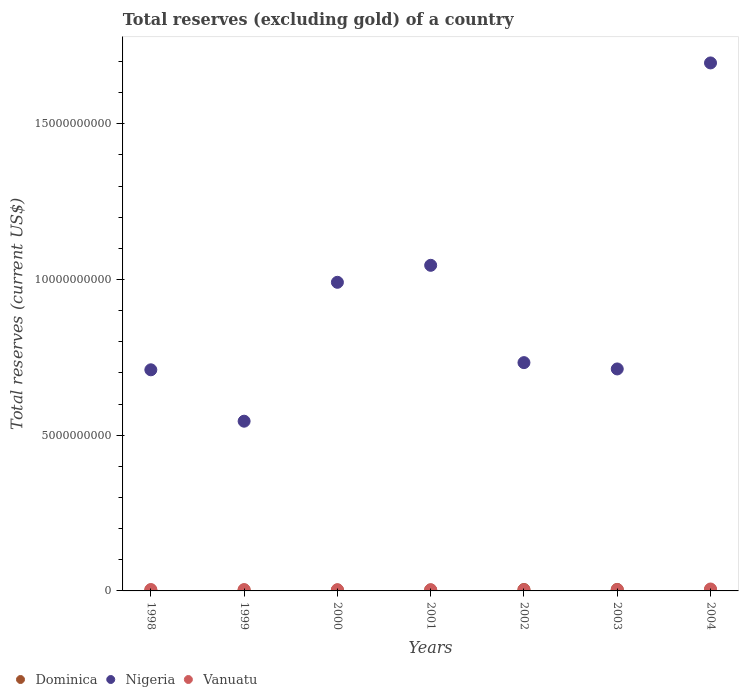How many different coloured dotlines are there?
Keep it short and to the point. 3. What is the total reserves (excluding gold) in Vanuatu in 1998?
Provide a succinct answer. 4.47e+07. Across all years, what is the maximum total reserves (excluding gold) in Dominica?
Provide a succinct answer. 4.77e+07. Across all years, what is the minimum total reserves (excluding gold) in Nigeria?
Provide a short and direct response. 5.45e+09. In which year was the total reserves (excluding gold) in Dominica maximum?
Your response must be concise. 2003. What is the total total reserves (excluding gold) in Dominica in the graph?
Make the answer very short. 2.55e+08. What is the difference between the total reserves (excluding gold) in Nigeria in 2000 and that in 2003?
Your response must be concise. 2.78e+09. What is the difference between the total reserves (excluding gold) in Vanuatu in 1999 and the total reserves (excluding gold) in Nigeria in 2000?
Your answer should be very brief. -9.87e+09. What is the average total reserves (excluding gold) in Dominica per year?
Ensure brevity in your answer.  3.65e+07. In the year 2002, what is the difference between the total reserves (excluding gold) in Vanuatu and total reserves (excluding gold) in Nigeria?
Provide a short and direct response. -7.29e+09. In how many years, is the total reserves (excluding gold) in Dominica greater than 8000000000 US$?
Provide a short and direct response. 0. What is the ratio of the total reserves (excluding gold) in Nigeria in 1999 to that in 2000?
Offer a very short reply. 0.55. Is the difference between the total reserves (excluding gold) in Vanuatu in 1998 and 2002 greater than the difference between the total reserves (excluding gold) in Nigeria in 1998 and 2002?
Provide a short and direct response. Yes. What is the difference between the highest and the second highest total reserves (excluding gold) in Vanuatu?
Your response must be concise. 1.71e+07. What is the difference between the highest and the lowest total reserves (excluding gold) in Dominica?
Ensure brevity in your answer.  2.01e+07. In how many years, is the total reserves (excluding gold) in Dominica greater than the average total reserves (excluding gold) in Dominica taken over all years?
Provide a succinct answer. 3. Is it the case that in every year, the sum of the total reserves (excluding gold) in Nigeria and total reserves (excluding gold) in Vanuatu  is greater than the total reserves (excluding gold) in Dominica?
Make the answer very short. Yes. Does the total reserves (excluding gold) in Nigeria monotonically increase over the years?
Provide a short and direct response. No. Is the total reserves (excluding gold) in Nigeria strictly less than the total reserves (excluding gold) in Vanuatu over the years?
Keep it short and to the point. No. Where does the legend appear in the graph?
Your answer should be very brief. Bottom left. How are the legend labels stacked?
Offer a very short reply. Horizontal. What is the title of the graph?
Give a very brief answer. Total reserves (excluding gold) of a country. Does "Angola" appear as one of the legend labels in the graph?
Your response must be concise. No. What is the label or title of the Y-axis?
Your answer should be very brief. Total reserves (current US$). What is the Total reserves (current US$) in Dominica in 1998?
Offer a very short reply. 2.77e+07. What is the Total reserves (current US$) in Nigeria in 1998?
Keep it short and to the point. 7.10e+09. What is the Total reserves (current US$) of Vanuatu in 1998?
Your response must be concise. 4.47e+07. What is the Total reserves (current US$) in Dominica in 1999?
Provide a succinct answer. 3.16e+07. What is the Total reserves (current US$) of Nigeria in 1999?
Provide a succinct answer. 5.45e+09. What is the Total reserves (current US$) in Vanuatu in 1999?
Your response must be concise. 4.14e+07. What is the Total reserves (current US$) in Dominica in 2000?
Make the answer very short. 2.94e+07. What is the Total reserves (current US$) of Nigeria in 2000?
Give a very brief answer. 9.91e+09. What is the Total reserves (current US$) in Vanuatu in 2000?
Offer a terse response. 3.89e+07. What is the Total reserves (current US$) in Dominica in 2001?
Keep it short and to the point. 3.12e+07. What is the Total reserves (current US$) of Nigeria in 2001?
Give a very brief answer. 1.05e+1. What is the Total reserves (current US$) in Vanuatu in 2001?
Your response must be concise. 3.77e+07. What is the Total reserves (current US$) in Dominica in 2002?
Your answer should be very brief. 4.55e+07. What is the Total reserves (current US$) in Nigeria in 2002?
Ensure brevity in your answer.  7.33e+09. What is the Total reserves (current US$) of Vanuatu in 2002?
Give a very brief answer. 3.65e+07. What is the Total reserves (current US$) in Dominica in 2003?
Offer a very short reply. 4.77e+07. What is the Total reserves (current US$) of Nigeria in 2003?
Ensure brevity in your answer.  7.13e+09. What is the Total reserves (current US$) in Vanuatu in 2003?
Ensure brevity in your answer.  4.38e+07. What is the Total reserves (current US$) in Dominica in 2004?
Offer a terse response. 4.23e+07. What is the Total reserves (current US$) of Nigeria in 2004?
Your answer should be very brief. 1.70e+1. What is the Total reserves (current US$) in Vanuatu in 2004?
Offer a very short reply. 6.18e+07. Across all years, what is the maximum Total reserves (current US$) of Dominica?
Your response must be concise. 4.77e+07. Across all years, what is the maximum Total reserves (current US$) in Nigeria?
Make the answer very short. 1.70e+1. Across all years, what is the maximum Total reserves (current US$) in Vanuatu?
Your answer should be compact. 6.18e+07. Across all years, what is the minimum Total reserves (current US$) of Dominica?
Offer a terse response. 2.77e+07. Across all years, what is the minimum Total reserves (current US$) in Nigeria?
Provide a short and direct response. 5.45e+09. Across all years, what is the minimum Total reserves (current US$) of Vanuatu?
Your answer should be very brief. 3.65e+07. What is the total Total reserves (current US$) of Dominica in the graph?
Make the answer very short. 2.55e+08. What is the total Total reserves (current US$) in Nigeria in the graph?
Give a very brief answer. 6.43e+1. What is the total Total reserves (current US$) in Vanuatu in the graph?
Provide a succinct answer. 3.05e+08. What is the difference between the Total reserves (current US$) in Dominica in 1998 and that in 1999?
Ensure brevity in your answer.  -3.91e+06. What is the difference between the Total reserves (current US$) of Nigeria in 1998 and that in 1999?
Your answer should be very brief. 1.65e+09. What is the difference between the Total reserves (current US$) of Vanuatu in 1998 and that in 1999?
Keep it short and to the point. 3.32e+06. What is the difference between the Total reserves (current US$) in Dominica in 1998 and that in 2000?
Keep it short and to the point. -1.71e+06. What is the difference between the Total reserves (current US$) of Nigeria in 1998 and that in 2000?
Provide a succinct answer. -2.81e+09. What is the difference between the Total reserves (current US$) in Vanuatu in 1998 and that in 2000?
Your answer should be very brief. 5.75e+06. What is the difference between the Total reserves (current US$) in Dominica in 1998 and that in 2001?
Keep it short and to the point. -3.56e+06. What is the difference between the Total reserves (current US$) of Nigeria in 1998 and that in 2001?
Offer a terse response. -3.36e+09. What is the difference between the Total reserves (current US$) of Vanuatu in 1998 and that in 2001?
Give a very brief answer. 7.01e+06. What is the difference between the Total reserves (current US$) in Dominica in 1998 and that in 2002?
Offer a terse response. -1.78e+07. What is the difference between the Total reserves (current US$) in Nigeria in 1998 and that in 2002?
Offer a terse response. -2.31e+08. What is the difference between the Total reserves (current US$) of Vanuatu in 1998 and that in 2002?
Keep it short and to the point. 8.15e+06. What is the difference between the Total reserves (current US$) of Dominica in 1998 and that in 2003?
Your response must be concise. -2.01e+07. What is the difference between the Total reserves (current US$) of Nigeria in 1998 and that in 2003?
Offer a terse response. -2.76e+07. What is the difference between the Total reserves (current US$) in Vanuatu in 1998 and that in 2003?
Give a very brief answer. 8.53e+05. What is the difference between the Total reserves (current US$) in Dominica in 1998 and that in 2004?
Make the answer very short. -1.47e+07. What is the difference between the Total reserves (current US$) in Nigeria in 1998 and that in 2004?
Provide a short and direct response. -9.85e+09. What is the difference between the Total reserves (current US$) of Vanuatu in 1998 and that in 2004?
Offer a very short reply. -1.71e+07. What is the difference between the Total reserves (current US$) in Dominica in 1999 and that in 2000?
Provide a succinct answer. 2.20e+06. What is the difference between the Total reserves (current US$) in Nigeria in 1999 and that in 2000?
Your response must be concise. -4.46e+09. What is the difference between the Total reserves (current US$) in Vanuatu in 1999 and that in 2000?
Your answer should be very brief. 2.43e+06. What is the difference between the Total reserves (current US$) in Dominica in 1999 and that in 2001?
Your answer should be compact. 3.50e+05. What is the difference between the Total reserves (current US$) in Nigeria in 1999 and that in 2001?
Make the answer very short. -5.01e+09. What is the difference between the Total reserves (current US$) in Vanuatu in 1999 and that in 2001?
Make the answer very short. 3.70e+06. What is the difference between the Total reserves (current US$) of Dominica in 1999 and that in 2002?
Your answer should be compact. -1.39e+07. What is the difference between the Total reserves (current US$) in Nigeria in 1999 and that in 2002?
Offer a very short reply. -1.88e+09. What is the difference between the Total reserves (current US$) in Vanuatu in 1999 and that in 2002?
Provide a short and direct response. 4.83e+06. What is the difference between the Total reserves (current US$) of Dominica in 1999 and that in 2003?
Provide a succinct answer. -1.62e+07. What is the difference between the Total reserves (current US$) in Nigeria in 1999 and that in 2003?
Offer a very short reply. -1.68e+09. What is the difference between the Total reserves (current US$) in Vanuatu in 1999 and that in 2003?
Make the answer very short. -2.46e+06. What is the difference between the Total reserves (current US$) in Dominica in 1999 and that in 2004?
Provide a short and direct response. -1.07e+07. What is the difference between the Total reserves (current US$) of Nigeria in 1999 and that in 2004?
Make the answer very short. -1.15e+1. What is the difference between the Total reserves (current US$) of Vanuatu in 1999 and that in 2004?
Your answer should be compact. -2.05e+07. What is the difference between the Total reserves (current US$) of Dominica in 2000 and that in 2001?
Your answer should be compact. -1.85e+06. What is the difference between the Total reserves (current US$) in Nigeria in 2000 and that in 2001?
Keep it short and to the point. -5.46e+08. What is the difference between the Total reserves (current US$) of Vanuatu in 2000 and that in 2001?
Offer a terse response. 1.26e+06. What is the difference between the Total reserves (current US$) of Dominica in 2000 and that in 2002?
Offer a very short reply. -1.61e+07. What is the difference between the Total reserves (current US$) in Nigeria in 2000 and that in 2002?
Offer a terse response. 2.58e+09. What is the difference between the Total reserves (current US$) of Vanuatu in 2000 and that in 2002?
Ensure brevity in your answer.  2.40e+06. What is the difference between the Total reserves (current US$) in Dominica in 2000 and that in 2003?
Your answer should be very brief. -1.84e+07. What is the difference between the Total reserves (current US$) in Nigeria in 2000 and that in 2003?
Give a very brief answer. 2.78e+09. What is the difference between the Total reserves (current US$) of Vanuatu in 2000 and that in 2003?
Your answer should be very brief. -4.89e+06. What is the difference between the Total reserves (current US$) in Dominica in 2000 and that in 2004?
Provide a short and direct response. -1.29e+07. What is the difference between the Total reserves (current US$) in Nigeria in 2000 and that in 2004?
Your response must be concise. -7.04e+09. What is the difference between the Total reserves (current US$) of Vanuatu in 2000 and that in 2004?
Your answer should be compact. -2.29e+07. What is the difference between the Total reserves (current US$) of Dominica in 2001 and that in 2002?
Offer a very short reply. -1.43e+07. What is the difference between the Total reserves (current US$) in Nigeria in 2001 and that in 2002?
Your answer should be very brief. 3.13e+09. What is the difference between the Total reserves (current US$) in Vanuatu in 2001 and that in 2002?
Provide a short and direct response. 1.14e+06. What is the difference between the Total reserves (current US$) of Dominica in 2001 and that in 2003?
Offer a terse response. -1.65e+07. What is the difference between the Total reserves (current US$) of Nigeria in 2001 and that in 2003?
Offer a very short reply. 3.33e+09. What is the difference between the Total reserves (current US$) of Vanuatu in 2001 and that in 2003?
Provide a short and direct response. -6.16e+06. What is the difference between the Total reserves (current US$) of Dominica in 2001 and that in 2004?
Provide a succinct answer. -1.11e+07. What is the difference between the Total reserves (current US$) of Nigeria in 2001 and that in 2004?
Offer a very short reply. -6.50e+09. What is the difference between the Total reserves (current US$) in Vanuatu in 2001 and that in 2004?
Ensure brevity in your answer.  -2.42e+07. What is the difference between the Total reserves (current US$) of Dominica in 2002 and that in 2003?
Provide a short and direct response. -2.24e+06. What is the difference between the Total reserves (current US$) of Nigeria in 2002 and that in 2003?
Your answer should be very brief. 2.03e+08. What is the difference between the Total reserves (current US$) of Vanuatu in 2002 and that in 2003?
Provide a succinct answer. -7.29e+06. What is the difference between the Total reserves (current US$) of Dominica in 2002 and that in 2004?
Provide a short and direct response. 3.18e+06. What is the difference between the Total reserves (current US$) of Nigeria in 2002 and that in 2004?
Your response must be concise. -9.62e+09. What is the difference between the Total reserves (current US$) of Vanuatu in 2002 and that in 2004?
Your response must be concise. -2.53e+07. What is the difference between the Total reserves (current US$) in Dominica in 2003 and that in 2004?
Offer a terse response. 5.41e+06. What is the difference between the Total reserves (current US$) of Nigeria in 2003 and that in 2004?
Ensure brevity in your answer.  -9.83e+09. What is the difference between the Total reserves (current US$) in Vanuatu in 2003 and that in 2004?
Offer a very short reply. -1.80e+07. What is the difference between the Total reserves (current US$) of Dominica in 1998 and the Total reserves (current US$) of Nigeria in 1999?
Provide a short and direct response. -5.42e+09. What is the difference between the Total reserves (current US$) of Dominica in 1998 and the Total reserves (current US$) of Vanuatu in 1999?
Provide a succinct answer. -1.37e+07. What is the difference between the Total reserves (current US$) of Nigeria in 1998 and the Total reserves (current US$) of Vanuatu in 1999?
Keep it short and to the point. 7.06e+09. What is the difference between the Total reserves (current US$) in Dominica in 1998 and the Total reserves (current US$) in Nigeria in 2000?
Offer a very short reply. -9.88e+09. What is the difference between the Total reserves (current US$) in Dominica in 1998 and the Total reserves (current US$) in Vanuatu in 2000?
Offer a terse response. -1.13e+07. What is the difference between the Total reserves (current US$) of Nigeria in 1998 and the Total reserves (current US$) of Vanuatu in 2000?
Your response must be concise. 7.06e+09. What is the difference between the Total reserves (current US$) in Dominica in 1998 and the Total reserves (current US$) in Nigeria in 2001?
Make the answer very short. -1.04e+1. What is the difference between the Total reserves (current US$) in Dominica in 1998 and the Total reserves (current US$) in Vanuatu in 2001?
Make the answer very short. -9.99e+06. What is the difference between the Total reserves (current US$) in Nigeria in 1998 and the Total reserves (current US$) in Vanuatu in 2001?
Offer a very short reply. 7.06e+09. What is the difference between the Total reserves (current US$) of Dominica in 1998 and the Total reserves (current US$) of Nigeria in 2002?
Keep it short and to the point. -7.30e+09. What is the difference between the Total reserves (current US$) in Dominica in 1998 and the Total reserves (current US$) in Vanuatu in 2002?
Provide a short and direct response. -8.86e+06. What is the difference between the Total reserves (current US$) of Nigeria in 1998 and the Total reserves (current US$) of Vanuatu in 2002?
Offer a very short reply. 7.06e+09. What is the difference between the Total reserves (current US$) of Dominica in 1998 and the Total reserves (current US$) of Nigeria in 2003?
Offer a terse response. -7.10e+09. What is the difference between the Total reserves (current US$) of Dominica in 1998 and the Total reserves (current US$) of Vanuatu in 2003?
Keep it short and to the point. -1.62e+07. What is the difference between the Total reserves (current US$) of Nigeria in 1998 and the Total reserves (current US$) of Vanuatu in 2003?
Keep it short and to the point. 7.06e+09. What is the difference between the Total reserves (current US$) in Dominica in 1998 and the Total reserves (current US$) in Nigeria in 2004?
Give a very brief answer. -1.69e+1. What is the difference between the Total reserves (current US$) of Dominica in 1998 and the Total reserves (current US$) of Vanuatu in 2004?
Your answer should be very brief. -3.41e+07. What is the difference between the Total reserves (current US$) in Nigeria in 1998 and the Total reserves (current US$) in Vanuatu in 2004?
Provide a short and direct response. 7.04e+09. What is the difference between the Total reserves (current US$) in Dominica in 1999 and the Total reserves (current US$) in Nigeria in 2000?
Keep it short and to the point. -9.88e+09. What is the difference between the Total reserves (current US$) in Dominica in 1999 and the Total reserves (current US$) in Vanuatu in 2000?
Offer a very short reply. -7.35e+06. What is the difference between the Total reserves (current US$) in Nigeria in 1999 and the Total reserves (current US$) in Vanuatu in 2000?
Offer a very short reply. 5.41e+09. What is the difference between the Total reserves (current US$) in Dominica in 1999 and the Total reserves (current US$) in Nigeria in 2001?
Offer a terse response. -1.04e+1. What is the difference between the Total reserves (current US$) of Dominica in 1999 and the Total reserves (current US$) of Vanuatu in 2001?
Your response must be concise. -6.08e+06. What is the difference between the Total reserves (current US$) of Nigeria in 1999 and the Total reserves (current US$) of Vanuatu in 2001?
Offer a terse response. 5.41e+09. What is the difference between the Total reserves (current US$) in Dominica in 1999 and the Total reserves (current US$) in Nigeria in 2002?
Provide a short and direct response. -7.30e+09. What is the difference between the Total reserves (current US$) in Dominica in 1999 and the Total reserves (current US$) in Vanuatu in 2002?
Provide a short and direct response. -4.95e+06. What is the difference between the Total reserves (current US$) in Nigeria in 1999 and the Total reserves (current US$) in Vanuatu in 2002?
Give a very brief answer. 5.41e+09. What is the difference between the Total reserves (current US$) in Dominica in 1999 and the Total reserves (current US$) in Nigeria in 2003?
Offer a terse response. -7.10e+09. What is the difference between the Total reserves (current US$) of Dominica in 1999 and the Total reserves (current US$) of Vanuatu in 2003?
Keep it short and to the point. -1.22e+07. What is the difference between the Total reserves (current US$) in Nigeria in 1999 and the Total reserves (current US$) in Vanuatu in 2003?
Keep it short and to the point. 5.41e+09. What is the difference between the Total reserves (current US$) of Dominica in 1999 and the Total reserves (current US$) of Nigeria in 2004?
Give a very brief answer. -1.69e+1. What is the difference between the Total reserves (current US$) in Dominica in 1999 and the Total reserves (current US$) in Vanuatu in 2004?
Keep it short and to the point. -3.02e+07. What is the difference between the Total reserves (current US$) in Nigeria in 1999 and the Total reserves (current US$) in Vanuatu in 2004?
Keep it short and to the point. 5.39e+09. What is the difference between the Total reserves (current US$) in Dominica in 2000 and the Total reserves (current US$) in Nigeria in 2001?
Provide a short and direct response. -1.04e+1. What is the difference between the Total reserves (current US$) in Dominica in 2000 and the Total reserves (current US$) in Vanuatu in 2001?
Your answer should be compact. -8.29e+06. What is the difference between the Total reserves (current US$) in Nigeria in 2000 and the Total reserves (current US$) in Vanuatu in 2001?
Offer a very short reply. 9.87e+09. What is the difference between the Total reserves (current US$) in Dominica in 2000 and the Total reserves (current US$) in Nigeria in 2002?
Your answer should be very brief. -7.30e+09. What is the difference between the Total reserves (current US$) of Dominica in 2000 and the Total reserves (current US$) of Vanuatu in 2002?
Offer a very short reply. -7.15e+06. What is the difference between the Total reserves (current US$) in Nigeria in 2000 and the Total reserves (current US$) in Vanuatu in 2002?
Offer a terse response. 9.87e+09. What is the difference between the Total reserves (current US$) of Dominica in 2000 and the Total reserves (current US$) of Nigeria in 2003?
Provide a short and direct response. -7.10e+09. What is the difference between the Total reserves (current US$) of Dominica in 2000 and the Total reserves (current US$) of Vanuatu in 2003?
Ensure brevity in your answer.  -1.44e+07. What is the difference between the Total reserves (current US$) in Nigeria in 2000 and the Total reserves (current US$) in Vanuatu in 2003?
Make the answer very short. 9.87e+09. What is the difference between the Total reserves (current US$) of Dominica in 2000 and the Total reserves (current US$) of Nigeria in 2004?
Offer a very short reply. -1.69e+1. What is the difference between the Total reserves (current US$) of Dominica in 2000 and the Total reserves (current US$) of Vanuatu in 2004?
Ensure brevity in your answer.  -3.24e+07. What is the difference between the Total reserves (current US$) of Nigeria in 2000 and the Total reserves (current US$) of Vanuatu in 2004?
Your answer should be compact. 9.85e+09. What is the difference between the Total reserves (current US$) in Dominica in 2001 and the Total reserves (current US$) in Nigeria in 2002?
Your response must be concise. -7.30e+09. What is the difference between the Total reserves (current US$) of Dominica in 2001 and the Total reserves (current US$) of Vanuatu in 2002?
Your response must be concise. -5.30e+06. What is the difference between the Total reserves (current US$) of Nigeria in 2001 and the Total reserves (current US$) of Vanuatu in 2002?
Your response must be concise. 1.04e+1. What is the difference between the Total reserves (current US$) in Dominica in 2001 and the Total reserves (current US$) in Nigeria in 2003?
Give a very brief answer. -7.10e+09. What is the difference between the Total reserves (current US$) in Dominica in 2001 and the Total reserves (current US$) in Vanuatu in 2003?
Your response must be concise. -1.26e+07. What is the difference between the Total reserves (current US$) of Nigeria in 2001 and the Total reserves (current US$) of Vanuatu in 2003?
Your answer should be very brief. 1.04e+1. What is the difference between the Total reserves (current US$) in Dominica in 2001 and the Total reserves (current US$) in Nigeria in 2004?
Make the answer very short. -1.69e+1. What is the difference between the Total reserves (current US$) of Dominica in 2001 and the Total reserves (current US$) of Vanuatu in 2004?
Offer a terse response. -3.06e+07. What is the difference between the Total reserves (current US$) in Nigeria in 2001 and the Total reserves (current US$) in Vanuatu in 2004?
Provide a short and direct response. 1.04e+1. What is the difference between the Total reserves (current US$) of Dominica in 2002 and the Total reserves (current US$) of Nigeria in 2003?
Offer a terse response. -7.08e+09. What is the difference between the Total reserves (current US$) in Dominica in 2002 and the Total reserves (current US$) in Vanuatu in 2003?
Keep it short and to the point. 1.68e+06. What is the difference between the Total reserves (current US$) in Nigeria in 2002 and the Total reserves (current US$) in Vanuatu in 2003?
Your response must be concise. 7.29e+09. What is the difference between the Total reserves (current US$) of Dominica in 2002 and the Total reserves (current US$) of Nigeria in 2004?
Ensure brevity in your answer.  -1.69e+1. What is the difference between the Total reserves (current US$) of Dominica in 2002 and the Total reserves (current US$) of Vanuatu in 2004?
Offer a terse response. -1.63e+07. What is the difference between the Total reserves (current US$) of Nigeria in 2002 and the Total reserves (current US$) of Vanuatu in 2004?
Offer a terse response. 7.27e+09. What is the difference between the Total reserves (current US$) of Dominica in 2003 and the Total reserves (current US$) of Nigeria in 2004?
Provide a succinct answer. -1.69e+1. What is the difference between the Total reserves (current US$) in Dominica in 2003 and the Total reserves (current US$) in Vanuatu in 2004?
Your response must be concise. -1.41e+07. What is the difference between the Total reserves (current US$) in Nigeria in 2003 and the Total reserves (current US$) in Vanuatu in 2004?
Ensure brevity in your answer.  7.07e+09. What is the average Total reserves (current US$) of Dominica per year?
Provide a succinct answer. 3.65e+07. What is the average Total reserves (current US$) of Nigeria per year?
Your response must be concise. 9.19e+09. What is the average Total reserves (current US$) of Vanuatu per year?
Provide a short and direct response. 4.35e+07. In the year 1998, what is the difference between the Total reserves (current US$) in Dominica and Total reserves (current US$) in Nigeria?
Provide a succinct answer. -7.07e+09. In the year 1998, what is the difference between the Total reserves (current US$) in Dominica and Total reserves (current US$) in Vanuatu?
Provide a succinct answer. -1.70e+07. In the year 1998, what is the difference between the Total reserves (current US$) of Nigeria and Total reserves (current US$) of Vanuatu?
Provide a succinct answer. 7.06e+09. In the year 1999, what is the difference between the Total reserves (current US$) of Dominica and Total reserves (current US$) of Nigeria?
Offer a very short reply. -5.42e+09. In the year 1999, what is the difference between the Total reserves (current US$) of Dominica and Total reserves (current US$) of Vanuatu?
Keep it short and to the point. -9.78e+06. In the year 1999, what is the difference between the Total reserves (current US$) in Nigeria and Total reserves (current US$) in Vanuatu?
Provide a succinct answer. 5.41e+09. In the year 2000, what is the difference between the Total reserves (current US$) in Dominica and Total reserves (current US$) in Nigeria?
Offer a terse response. -9.88e+09. In the year 2000, what is the difference between the Total reserves (current US$) of Dominica and Total reserves (current US$) of Vanuatu?
Keep it short and to the point. -9.55e+06. In the year 2000, what is the difference between the Total reserves (current US$) of Nigeria and Total reserves (current US$) of Vanuatu?
Make the answer very short. 9.87e+09. In the year 2001, what is the difference between the Total reserves (current US$) in Dominica and Total reserves (current US$) in Nigeria?
Your answer should be compact. -1.04e+1. In the year 2001, what is the difference between the Total reserves (current US$) in Dominica and Total reserves (current US$) in Vanuatu?
Ensure brevity in your answer.  -6.43e+06. In the year 2001, what is the difference between the Total reserves (current US$) in Nigeria and Total reserves (current US$) in Vanuatu?
Your response must be concise. 1.04e+1. In the year 2002, what is the difference between the Total reserves (current US$) of Dominica and Total reserves (current US$) of Nigeria?
Your answer should be compact. -7.29e+09. In the year 2002, what is the difference between the Total reserves (current US$) in Dominica and Total reserves (current US$) in Vanuatu?
Your response must be concise. 8.98e+06. In the year 2002, what is the difference between the Total reserves (current US$) in Nigeria and Total reserves (current US$) in Vanuatu?
Offer a very short reply. 7.29e+09. In the year 2003, what is the difference between the Total reserves (current US$) in Dominica and Total reserves (current US$) in Nigeria?
Keep it short and to the point. -7.08e+09. In the year 2003, what is the difference between the Total reserves (current US$) of Dominica and Total reserves (current US$) of Vanuatu?
Make the answer very short. 3.92e+06. In the year 2003, what is the difference between the Total reserves (current US$) of Nigeria and Total reserves (current US$) of Vanuatu?
Offer a terse response. 7.08e+09. In the year 2004, what is the difference between the Total reserves (current US$) of Dominica and Total reserves (current US$) of Nigeria?
Give a very brief answer. -1.69e+1. In the year 2004, what is the difference between the Total reserves (current US$) of Dominica and Total reserves (current US$) of Vanuatu?
Ensure brevity in your answer.  -1.95e+07. In the year 2004, what is the difference between the Total reserves (current US$) in Nigeria and Total reserves (current US$) in Vanuatu?
Provide a short and direct response. 1.69e+1. What is the ratio of the Total reserves (current US$) of Dominica in 1998 to that in 1999?
Give a very brief answer. 0.88. What is the ratio of the Total reserves (current US$) in Nigeria in 1998 to that in 1999?
Ensure brevity in your answer.  1.3. What is the ratio of the Total reserves (current US$) in Vanuatu in 1998 to that in 1999?
Make the answer very short. 1.08. What is the ratio of the Total reserves (current US$) in Dominica in 1998 to that in 2000?
Keep it short and to the point. 0.94. What is the ratio of the Total reserves (current US$) in Nigeria in 1998 to that in 2000?
Your answer should be compact. 0.72. What is the ratio of the Total reserves (current US$) in Vanuatu in 1998 to that in 2000?
Ensure brevity in your answer.  1.15. What is the ratio of the Total reserves (current US$) in Dominica in 1998 to that in 2001?
Provide a succinct answer. 0.89. What is the ratio of the Total reserves (current US$) in Nigeria in 1998 to that in 2001?
Ensure brevity in your answer.  0.68. What is the ratio of the Total reserves (current US$) in Vanuatu in 1998 to that in 2001?
Provide a succinct answer. 1.19. What is the ratio of the Total reserves (current US$) in Dominica in 1998 to that in 2002?
Give a very brief answer. 0.61. What is the ratio of the Total reserves (current US$) of Nigeria in 1998 to that in 2002?
Ensure brevity in your answer.  0.97. What is the ratio of the Total reserves (current US$) in Vanuatu in 1998 to that in 2002?
Make the answer very short. 1.22. What is the ratio of the Total reserves (current US$) in Dominica in 1998 to that in 2003?
Offer a terse response. 0.58. What is the ratio of the Total reserves (current US$) in Vanuatu in 1998 to that in 2003?
Keep it short and to the point. 1.02. What is the ratio of the Total reserves (current US$) in Dominica in 1998 to that in 2004?
Keep it short and to the point. 0.65. What is the ratio of the Total reserves (current US$) of Nigeria in 1998 to that in 2004?
Give a very brief answer. 0.42. What is the ratio of the Total reserves (current US$) in Vanuatu in 1998 to that in 2004?
Keep it short and to the point. 0.72. What is the ratio of the Total reserves (current US$) of Dominica in 1999 to that in 2000?
Keep it short and to the point. 1.07. What is the ratio of the Total reserves (current US$) in Nigeria in 1999 to that in 2000?
Keep it short and to the point. 0.55. What is the ratio of the Total reserves (current US$) in Vanuatu in 1999 to that in 2000?
Your response must be concise. 1.06. What is the ratio of the Total reserves (current US$) of Dominica in 1999 to that in 2001?
Provide a short and direct response. 1.01. What is the ratio of the Total reserves (current US$) in Nigeria in 1999 to that in 2001?
Give a very brief answer. 0.52. What is the ratio of the Total reserves (current US$) in Vanuatu in 1999 to that in 2001?
Your answer should be very brief. 1.1. What is the ratio of the Total reserves (current US$) in Dominica in 1999 to that in 2002?
Make the answer very short. 0.69. What is the ratio of the Total reserves (current US$) of Nigeria in 1999 to that in 2002?
Provide a succinct answer. 0.74. What is the ratio of the Total reserves (current US$) in Vanuatu in 1999 to that in 2002?
Your answer should be compact. 1.13. What is the ratio of the Total reserves (current US$) in Dominica in 1999 to that in 2003?
Give a very brief answer. 0.66. What is the ratio of the Total reserves (current US$) in Nigeria in 1999 to that in 2003?
Offer a very short reply. 0.76. What is the ratio of the Total reserves (current US$) of Vanuatu in 1999 to that in 2003?
Provide a short and direct response. 0.94. What is the ratio of the Total reserves (current US$) in Dominica in 1999 to that in 2004?
Offer a terse response. 0.75. What is the ratio of the Total reserves (current US$) of Nigeria in 1999 to that in 2004?
Keep it short and to the point. 0.32. What is the ratio of the Total reserves (current US$) of Vanuatu in 1999 to that in 2004?
Your answer should be compact. 0.67. What is the ratio of the Total reserves (current US$) of Dominica in 2000 to that in 2001?
Provide a succinct answer. 0.94. What is the ratio of the Total reserves (current US$) in Nigeria in 2000 to that in 2001?
Offer a very short reply. 0.95. What is the ratio of the Total reserves (current US$) in Vanuatu in 2000 to that in 2001?
Make the answer very short. 1.03. What is the ratio of the Total reserves (current US$) of Dominica in 2000 to that in 2002?
Give a very brief answer. 0.65. What is the ratio of the Total reserves (current US$) in Nigeria in 2000 to that in 2002?
Give a very brief answer. 1.35. What is the ratio of the Total reserves (current US$) in Vanuatu in 2000 to that in 2002?
Offer a terse response. 1.07. What is the ratio of the Total reserves (current US$) of Dominica in 2000 to that in 2003?
Provide a succinct answer. 0.62. What is the ratio of the Total reserves (current US$) of Nigeria in 2000 to that in 2003?
Your answer should be compact. 1.39. What is the ratio of the Total reserves (current US$) in Vanuatu in 2000 to that in 2003?
Your answer should be very brief. 0.89. What is the ratio of the Total reserves (current US$) in Dominica in 2000 to that in 2004?
Give a very brief answer. 0.69. What is the ratio of the Total reserves (current US$) of Nigeria in 2000 to that in 2004?
Your answer should be very brief. 0.58. What is the ratio of the Total reserves (current US$) in Vanuatu in 2000 to that in 2004?
Offer a terse response. 0.63. What is the ratio of the Total reserves (current US$) in Dominica in 2001 to that in 2002?
Your response must be concise. 0.69. What is the ratio of the Total reserves (current US$) in Nigeria in 2001 to that in 2002?
Provide a short and direct response. 1.43. What is the ratio of the Total reserves (current US$) of Vanuatu in 2001 to that in 2002?
Offer a very short reply. 1.03. What is the ratio of the Total reserves (current US$) of Dominica in 2001 to that in 2003?
Give a very brief answer. 0.65. What is the ratio of the Total reserves (current US$) in Nigeria in 2001 to that in 2003?
Offer a terse response. 1.47. What is the ratio of the Total reserves (current US$) of Vanuatu in 2001 to that in 2003?
Make the answer very short. 0.86. What is the ratio of the Total reserves (current US$) of Dominica in 2001 to that in 2004?
Offer a very short reply. 0.74. What is the ratio of the Total reserves (current US$) in Nigeria in 2001 to that in 2004?
Your response must be concise. 0.62. What is the ratio of the Total reserves (current US$) of Vanuatu in 2001 to that in 2004?
Provide a short and direct response. 0.61. What is the ratio of the Total reserves (current US$) in Dominica in 2002 to that in 2003?
Provide a short and direct response. 0.95. What is the ratio of the Total reserves (current US$) of Nigeria in 2002 to that in 2003?
Offer a very short reply. 1.03. What is the ratio of the Total reserves (current US$) in Vanuatu in 2002 to that in 2003?
Make the answer very short. 0.83. What is the ratio of the Total reserves (current US$) of Dominica in 2002 to that in 2004?
Provide a succinct answer. 1.07. What is the ratio of the Total reserves (current US$) in Nigeria in 2002 to that in 2004?
Your response must be concise. 0.43. What is the ratio of the Total reserves (current US$) of Vanuatu in 2002 to that in 2004?
Provide a short and direct response. 0.59. What is the ratio of the Total reserves (current US$) of Dominica in 2003 to that in 2004?
Keep it short and to the point. 1.13. What is the ratio of the Total reserves (current US$) in Nigeria in 2003 to that in 2004?
Ensure brevity in your answer.  0.42. What is the ratio of the Total reserves (current US$) of Vanuatu in 2003 to that in 2004?
Offer a terse response. 0.71. What is the difference between the highest and the second highest Total reserves (current US$) in Dominica?
Provide a short and direct response. 2.24e+06. What is the difference between the highest and the second highest Total reserves (current US$) of Nigeria?
Give a very brief answer. 6.50e+09. What is the difference between the highest and the second highest Total reserves (current US$) in Vanuatu?
Give a very brief answer. 1.71e+07. What is the difference between the highest and the lowest Total reserves (current US$) in Dominica?
Your answer should be very brief. 2.01e+07. What is the difference between the highest and the lowest Total reserves (current US$) of Nigeria?
Offer a terse response. 1.15e+1. What is the difference between the highest and the lowest Total reserves (current US$) of Vanuatu?
Provide a succinct answer. 2.53e+07. 